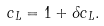Convert formula to latex. <formula><loc_0><loc_0><loc_500><loc_500>c _ { L } = 1 + \delta c _ { L } .</formula> 